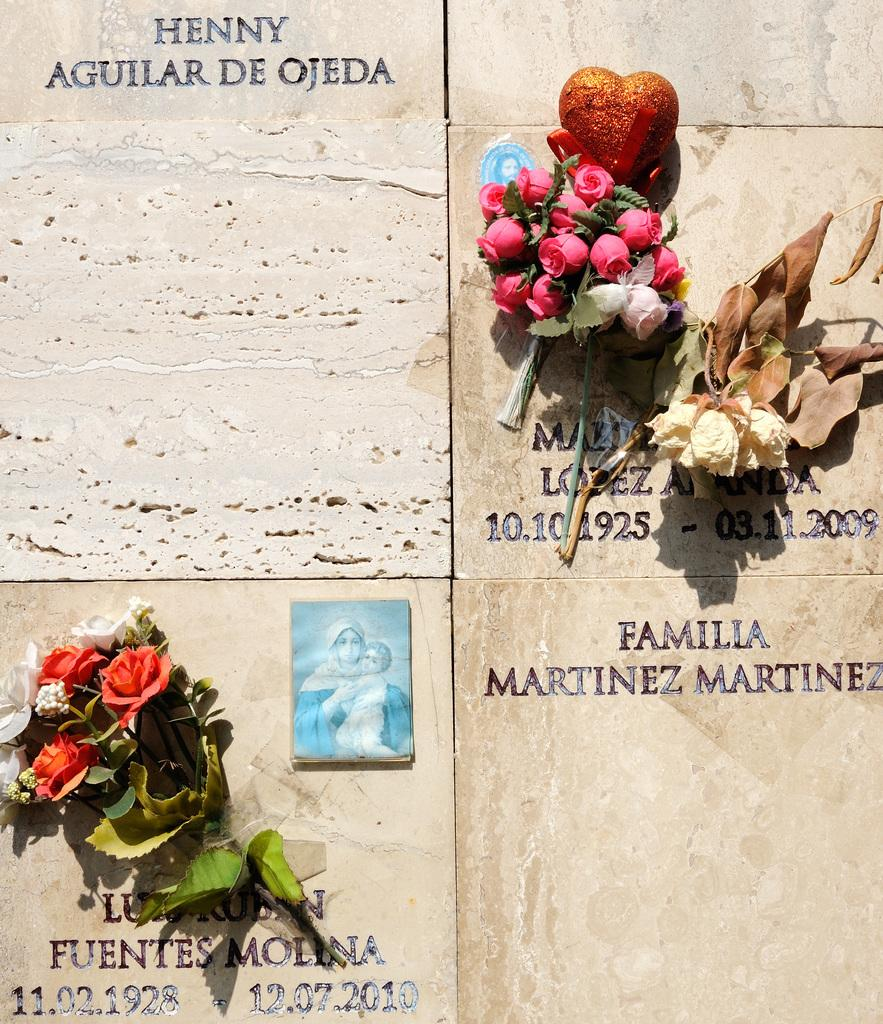What type of decorative items can be seen in the image? There are bouquets in the image. What else is present on the walls in the image? There are wall hangings in the image. Can you describe any text or writing on the walls in the image? Yes, there is text on the wall in the image. What type of transport is visible in the image? There is no transport visible in the image; it features bouquets and wall hangings. What authority is responsible for the text on the wall in the image? There is no indication of any authority responsible for the text on the wall in the image. 